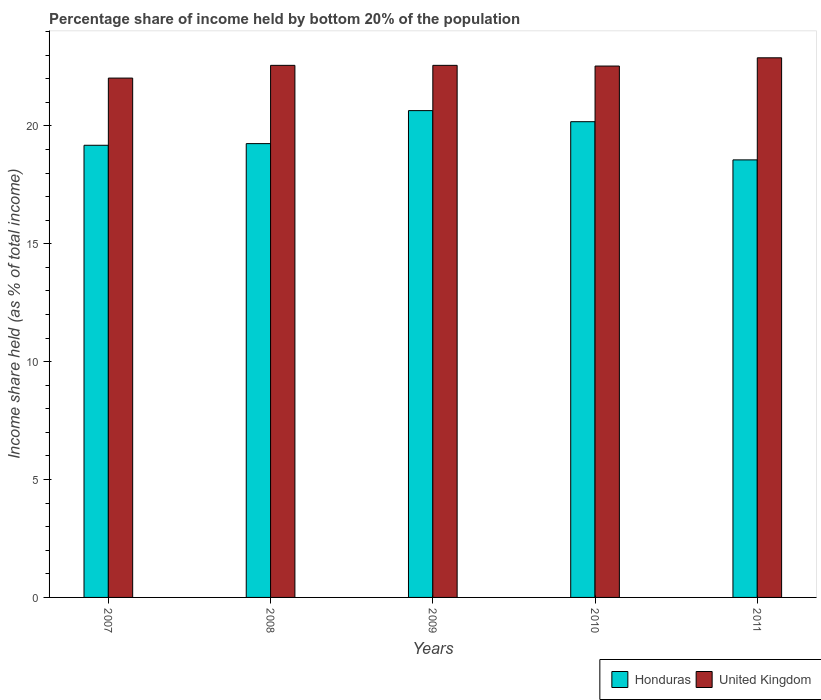Are the number of bars per tick equal to the number of legend labels?
Offer a terse response. Yes. How many bars are there on the 5th tick from the right?
Provide a succinct answer. 2. What is the label of the 2nd group of bars from the left?
Offer a terse response. 2008. What is the share of income held by bottom 20% of the population in United Kingdom in 2010?
Your response must be concise. 22.54. Across all years, what is the maximum share of income held by bottom 20% of the population in United Kingdom?
Give a very brief answer. 22.89. Across all years, what is the minimum share of income held by bottom 20% of the population in Honduras?
Your answer should be very brief. 18.56. In which year was the share of income held by bottom 20% of the population in United Kingdom maximum?
Provide a short and direct response. 2011. In which year was the share of income held by bottom 20% of the population in United Kingdom minimum?
Give a very brief answer. 2007. What is the total share of income held by bottom 20% of the population in Honduras in the graph?
Ensure brevity in your answer.  97.82. What is the difference between the share of income held by bottom 20% of the population in United Kingdom in 2009 and that in 2011?
Your response must be concise. -0.32. What is the difference between the share of income held by bottom 20% of the population in United Kingdom in 2007 and the share of income held by bottom 20% of the population in Honduras in 2008?
Your answer should be compact. 2.78. What is the average share of income held by bottom 20% of the population in United Kingdom per year?
Give a very brief answer. 22.52. In the year 2009, what is the difference between the share of income held by bottom 20% of the population in United Kingdom and share of income held by bottom 20% of the population in Honduras?
Provide a short and direct response. 1.92. In how many years, is the share of income held by bottom 20% of the population in United Kingdom greater than 14 %?
Offer a terse response. 5. What is the ratio of the share of income held by bottom 20% of the population in Honduras in 2007 to that in 2011?
Provide a short and direct response. 1.03. Is the share of income held by bottom 20% of the population in United Kingdom in 2010 less than that in 2011?
Offer a very short reply. Yes. What is the difference between the highest and the second highest share of income held by bottom 20% of the population in Honduras?
Keep it short and to the point. 0.47. What is the difference between the highest and the lowest share of income held by bottom 20% of the population in United Kingdom?
Your answer should be very brief. 0.86. What does the 2nd bar from the right in 2007 represents?
Ensure brevity in your answer.  Honduras. How many bars are there?
Offer a terse response. 10. What is the difference between two consecutive major ticks on the Y-axis?
Offer a very short reply. 5. Are the values on the major ticks of Y-axis written in scientific E-notation?
Provide a short and direct response. No. Does the graph contain grids?
Your answer should be very brief. No. How are the legend labels stacked?
Keep it short and to the point. Horizontal. What is the title of the graph?
Provide a short and direct response. Percentage share of income held by bottom 20% of the population. Does "Middle East & North Africa (developing only)" appear as one of the legend labels in the graph?
Your response must be concise. No. What is the label or title of the X-axis?
Provide a succinct answer. Years. What is the label or title of the Y-axis?
Offer a very short reply. Income share held (as % of total income). What is the Income share held (as % of total income) of Honduras in 2007?
Your response must be concise. 19.18. What is the Income share held (as % of total income) in United Kingdom in 2007?
Make the answer very short. 22.03. What is the Income share held (as % of total income) of Honduras in 2008?
Give a very brief answer. 19.25. What is the Income share held (as % of total income) in United Kingdom in 2008?
Offer a terse response. 22.57. What is the Income share held (as % of total income) of Honduras in 2009?
Make the answer very short. 20.65. What is the Income share held (as % of total income) in United Kingdom in 2009?
Provide a short and direct response. 22.57. What is the Income share held (as % of total income) of Honduras in 2010?
Give a very brief answer. 20.18. What is the Income share held (as % of total income) in United Kingdom in 2010?
Your answer should be very brief. 22.54. What is the Income share held (as % of total income) of Honduras in 2011?
Provide a succinct answer. 18.56. What is the Income share held (as % of total income) of United Kingdom in 2011?
Your answer should be very brief. 22.89. Across all years, what is the maximum Income share held (as % of total income) of Honduras?
Provide a succinct answer. 20.65. Across all years, what is the maximum Income share held (as % of total income) of United Kingdom?
Your answer should be very brief. 22.89. Across all years, what is the minimum Income share held (as % of total income) in Honduras?
Offer a terse response. 18.56. Across all years, what is the minimum Income share held (as % of total income) in United Kingdom?
Offer a terse response. 22.03. What is the total Income share held (as % of total income) in Honduras in the graph?
Provide a short and direct response. 97.82. What is the total Income share held (as % of total income) of United Kingdom in the graph?
Ensure brevity in your answer.  112.6. What is the difference between the Income share held (as % of total income) of Honduras in 2007 and that in 2008?
Your response must be concise. -0.07. What is the difference between the Income share held (as % of total income) in United Kingdom in 2007 and that in 2008?
Ensure brevity in your answer.  -0.54. What is the difference between the Income share held (as % of total income) in Honduras in 2007 and that in 2009?
Offer a terse response. -1.47. What is the difference between the Income share held (as % of total income) in United Kingdom in 2007 and that in 2009?
Provide a succinct answer. -0.54. What is the difference between the Income share held (as % of total income) in Honduras in 2007 and that in 2010?
Offer a terse response. -1. What is the difference between the Income share held (as % of total income) of United Kingdom in 2007 and that in 2010?
Your response must be concise. -0.51. What is the difference between the Income share held (as % of total income) of Honduras in 2007 and that in 2011?
Your response must be concise. 0.62. What is the difference between the Income share held (as % of total income) in United Kingdom in 2007 and that in 2011?
Your answer should be very brief. -0.86. What is the difference between the Income share held (as % of total income) of Honduras in 2008 and that in 2009?
Offer a very short reply. -1.4. What is the difference between the Income share held (as % of total income) in Honduras in 2008 and that in 2010?
Your answer should be compact. -0.93. What is the difference between the Income share held (as % of total income) of Honduras in 2008 and that in 2011?
Provide a succinct answer. 0.69. What is the difference between the Income share held (as % of total income) in United Kingdom in 2008 and that in 2011?
Ensure brevity in your answer.  -0.32. What is the difference between the Income share held (as % of total income) in Honduras in 2009 and that in 2010?
Keep it short and to the point. 0.47. What is the difference between the Income share held (as % of total income) of United Kingdom in 2009 and that in 2010?
Ensure brevity in your answer.  0.03. What is the difference between the Income share held (as % of total income) of Honduras in 2009 and that in 2011?
Offer a terse response. 2.09. What is the difference between the Income share held (as % of total income) of United Kingdom in 2009 and that in 2011?
Make the answer very short. -0.32. What is the difference between the Income share held (as % of total income) in Honduras in 2010 and that in 2011?
Make the answer very short. 1.62. What is the difference between the Income share held (as % of total income) of United Kingdom in 2010 and that in 2011?
Provide a succinct answer. -0.35. What is the difference between the Income share held (as % of total income) of Honduras in 2007 and the Income share held (as % of total income) of United Kingdom in 2008?
Keep it short and to the point. -3.39. What is the difference between the Income share held (as % of total income) in Honduras in 2007 and the Income share held (as % of total income) in United Kingdom in 2009?
Give a very brief answer. -3.39. What is the difference between the Income share held (as % of total income) of Honduras in 2007 and the Income share held (as % of total income) of United Kingdom in 2010?
Offer a terse response. -3.36. What is the difference between the Income share held (as % of total income) in Honduras in 2007 and the Income share held (as % of total income) in United Kingdom in 2011?
Make the answer very short. -3.71. What is the difference between the Income share held (as % of total income) in Honduras in 2008 and the Income share held (as % of total income) in United Kingdom in 2009?
Keep it short and to the point. -3.32. What is the difference between the Income share held (as % of total income) in Honduras in 2008 and the Income share held (as % of total income) in United Kingdom in 2010?
Your response must be concise. -3.29. What is the difference between the Income share held (as % of total income) of Honduras in 2008 and the Income share held (as % of total income) of United Kingdom in 2011?
Keep it short and to the point. -3.64. What is the difference between the Income share held (as % of total income) in Honduras in 2009 and the Income share held (as % of total income) in United Kingdom in 2010?
Ensure brevity in your answer.  -1.89. What is the difference between the Income share held (as % of total income) in Honduras in 2009 and the Income share held (as % of total income) in United Kingdom in 2011?
Your answer should be very brief. -2.24. What is the difference between the Income share held (as % of total income) in Honduras in 2010 and the Income share held (as % of total income) in United Kingdom in 2011?
Give a very brief answer. -2.71. What is the average Income share held (as % of total income) of Honduras per year?
Your response must be concise. 19.56. What is the average Income share held (as % of total income) in United Kingdom per year?
Your answer should be very brief. 22.52. In the year 2007, what is the difference between the Income share held (as % of total income) of Honduras and Income share held (as % of total income) of United Kingdom?
Make the answer very short. -2.85. In the year 2008, what is the difference between the Income share held (as % of total income) in Honduras and Income share held (as % of total income) in United Kingdom?
Offer a very short reply. -3.32. In the year 2009, what is the difference between the Income share held (as % of total income) in Honduras and Income share held (as % of total income) in United Kingdom?
Offer a terse response. -1.92. In the year 2010, what is the difference between the Income share held (as % of total income) in Honduras and Income share held (as % of total income) in United Kingdom?
Give a very brief answer. -2.36. In the year 2011, what is the difference between the Income share held (as % of total income) in Honduras and Income share held (as % of total income) in United Kingdom?
Your response must be concise. -4.33. What is the ratio of the Income share held (as % of total income) in United Kingdom in 2007 to that in 2008?
Your answer should be very brief. 0.98. What is the ratio of the Income share held (as % of total income) of Honduras in 2007 to that in 2009?
Offer a terse response. 0.93. What is the ratio of the Income share held (as % of total income) of United Kingdom in 2007 to that in 2009?
Your answer should be compact. 0.98. What is the ratio of the Income share held (as % of total income) of Honduras in 2007 to that in 2010?
Make the answer very short. 0.95. What is the ratio of the Income share held (as % of total income) of United Kingdom in 2007 to that in 2010?
Your answer should be very brief. 0.98. What is the ratio of the Income share held (as % of total income) in Honduras in 2007 to that in 2011?
Give a very brief answer. 1.03. What is the ratio of the Income share held (as % of total income) of United Kingdom in 2007 to that in 2011?
Your answer should be compact. 0.96. What is the ratio of the Income share held (as % of total income) in Honduras in 2008 to that in 2009?
Give a very brief answer. 0.93. What is the ratio of the Income share held (as % of total income) in Honduras in 2008 to that in 2010?
Offer a very short reply. 0.95. What is the ratio of the Income share held (as % of total income) in Honduras in 2008 to that in 2011?
Your answer should be compact. 1.04. What is the ratio of the Income share held (as % of total income) of United Kingdom in 2008 to that in 2011?
Provide a short and direct response. 0.99. What is the ratio of the Income share held (as % of total income) of Honduras in 2009 to that in 2010?
Your answer should be compact. 1.02. What is the ratio of the Income share held (as % of total income) of Honduras in 2009 to that in 2011?
Your response must be concise. 1.11. What is the ratio of the Income share held (as % of total income) of United Kingdom in 2009 to that in 2011?
Keep it short and to the point. 0.99. What is the ratio of the Income share held (as % of total income) in Honduras in 2010 to that in 2011?
Your answer should be very brief. 1.09. What is the ratio of the Income share held (as % of total income) in United Kingdom in 2010 to that in 2011?
Your answer should be compact. 0.98. What is the difference between the highest and the second highest Income share held (as % of total income) in Honduras?
Ensure brevity in your answer.  0.47. What is the difference between the highest and the second highest Income share held (as % of total income) in United Kingdom?
Keep it short and to the point. 0.32. What is the difference between the highest and the lowest Income share held (as % of total income) of Honduras?
Give a very brief answer. 2.09. What is the difference between the highest and the lowest Income share held (as % of total income) of United Kingdom?
Give a very brief answer. 0.86. 